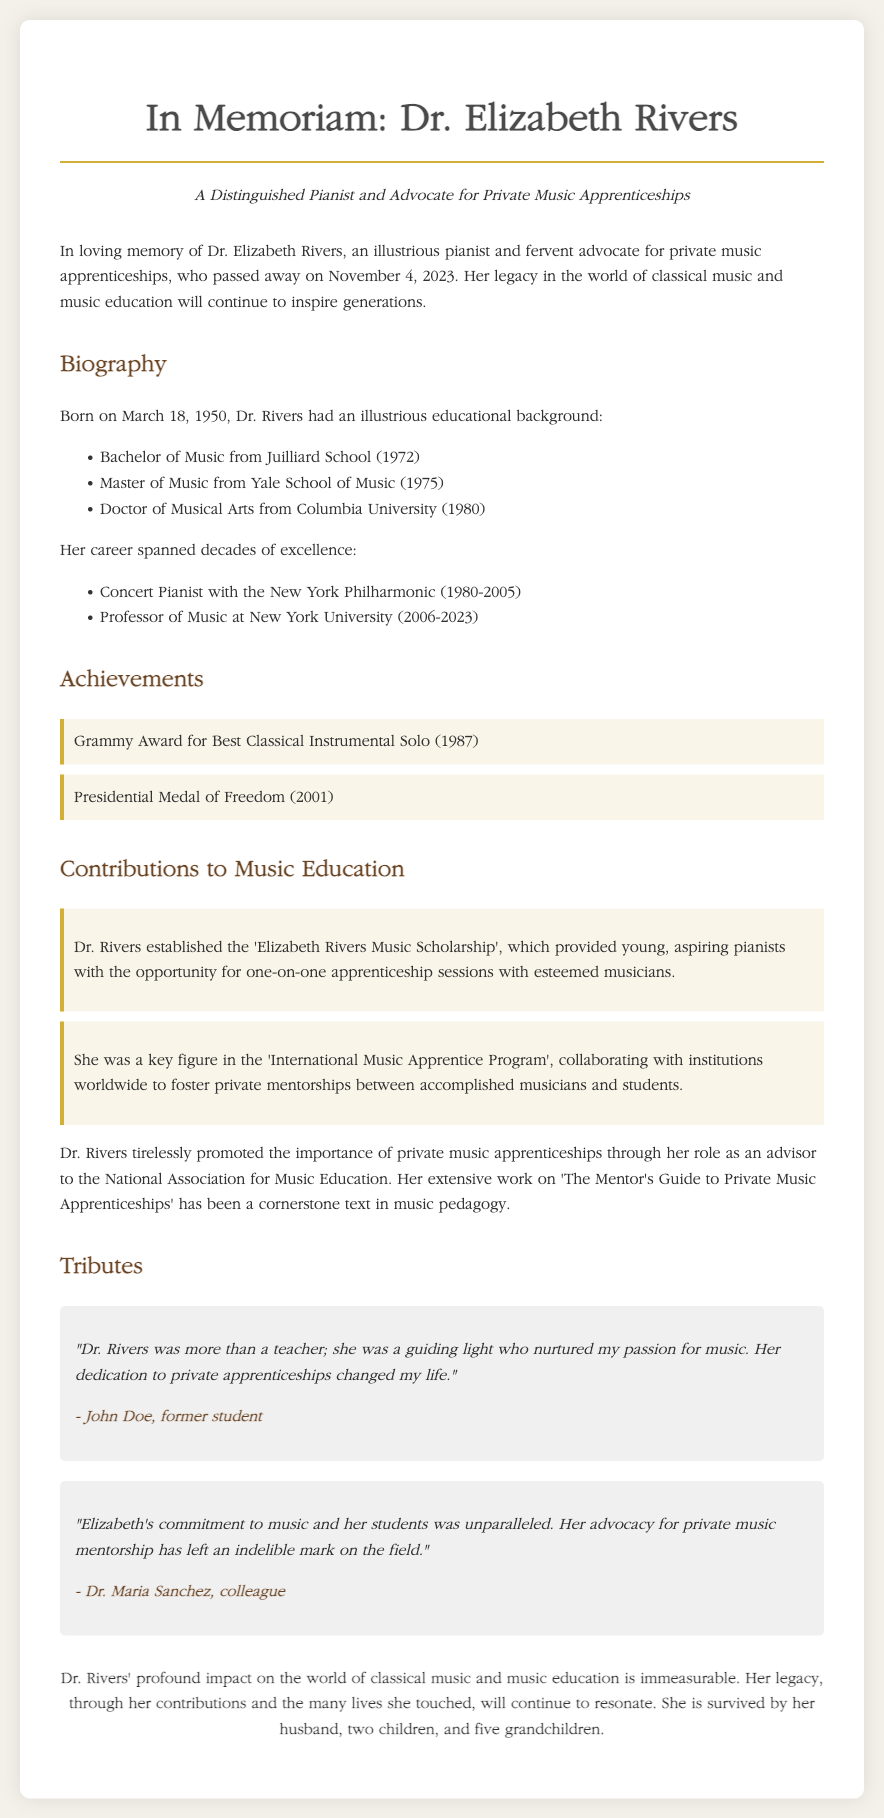What date did Dr. Elizabeth Rivers pass away? The document states that Dr. Elizabeth Rivers passed away on November 4, 2023.
Answer: November 4, 2023 What degree did Dr. Rivers earn from Juilliard School? The document lists that she earned a Bachelor of Music from Juilliard School in 1972.
Answer: Bachelor of Music What prestigious award did Dr. Rivers receive in 2001? The document mentions that she received the Presidential Medal of Freedom in 2001.
Answer: Presidential Medal of Freedom Which music program did Dr. Rivers collaborate with globally? The document states she was a key figure in the 'International Music Apprentice Program'.
Answer: International Music Apprentice Program Who is a former student that paid tribute to Dr. Rivers? The document includes a tribute from John Doe, a former student of Dr. Rivers.
Answer: John Doe What was the name of the scholarship established by Dr. Rivers? The document mentions the 'Elizabeth Rivers Music Scholarship' that she established.
Answer: Elizabeth Rivers Music Scholarship What role did Dr. Rivers serve in relation to the National Association for Music Education? The document states she was an advisor to the National Association for Music Education.
Answer: Advisor What year did Dr. Rivers start her position as a professor at New York University? According to the document, she became a professor at NYU in 2006.
Answer: 2006 